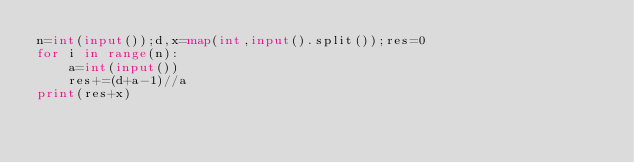Convert code to text. <code><loc_0><loc_0><loc_500><loc_500><_Python_>n=int(input());d,x=map(int,input().split());res=0
for i in range(n):
    a=int(input())
    res+=(d+a-1)//a
print(res+x)
</code> 